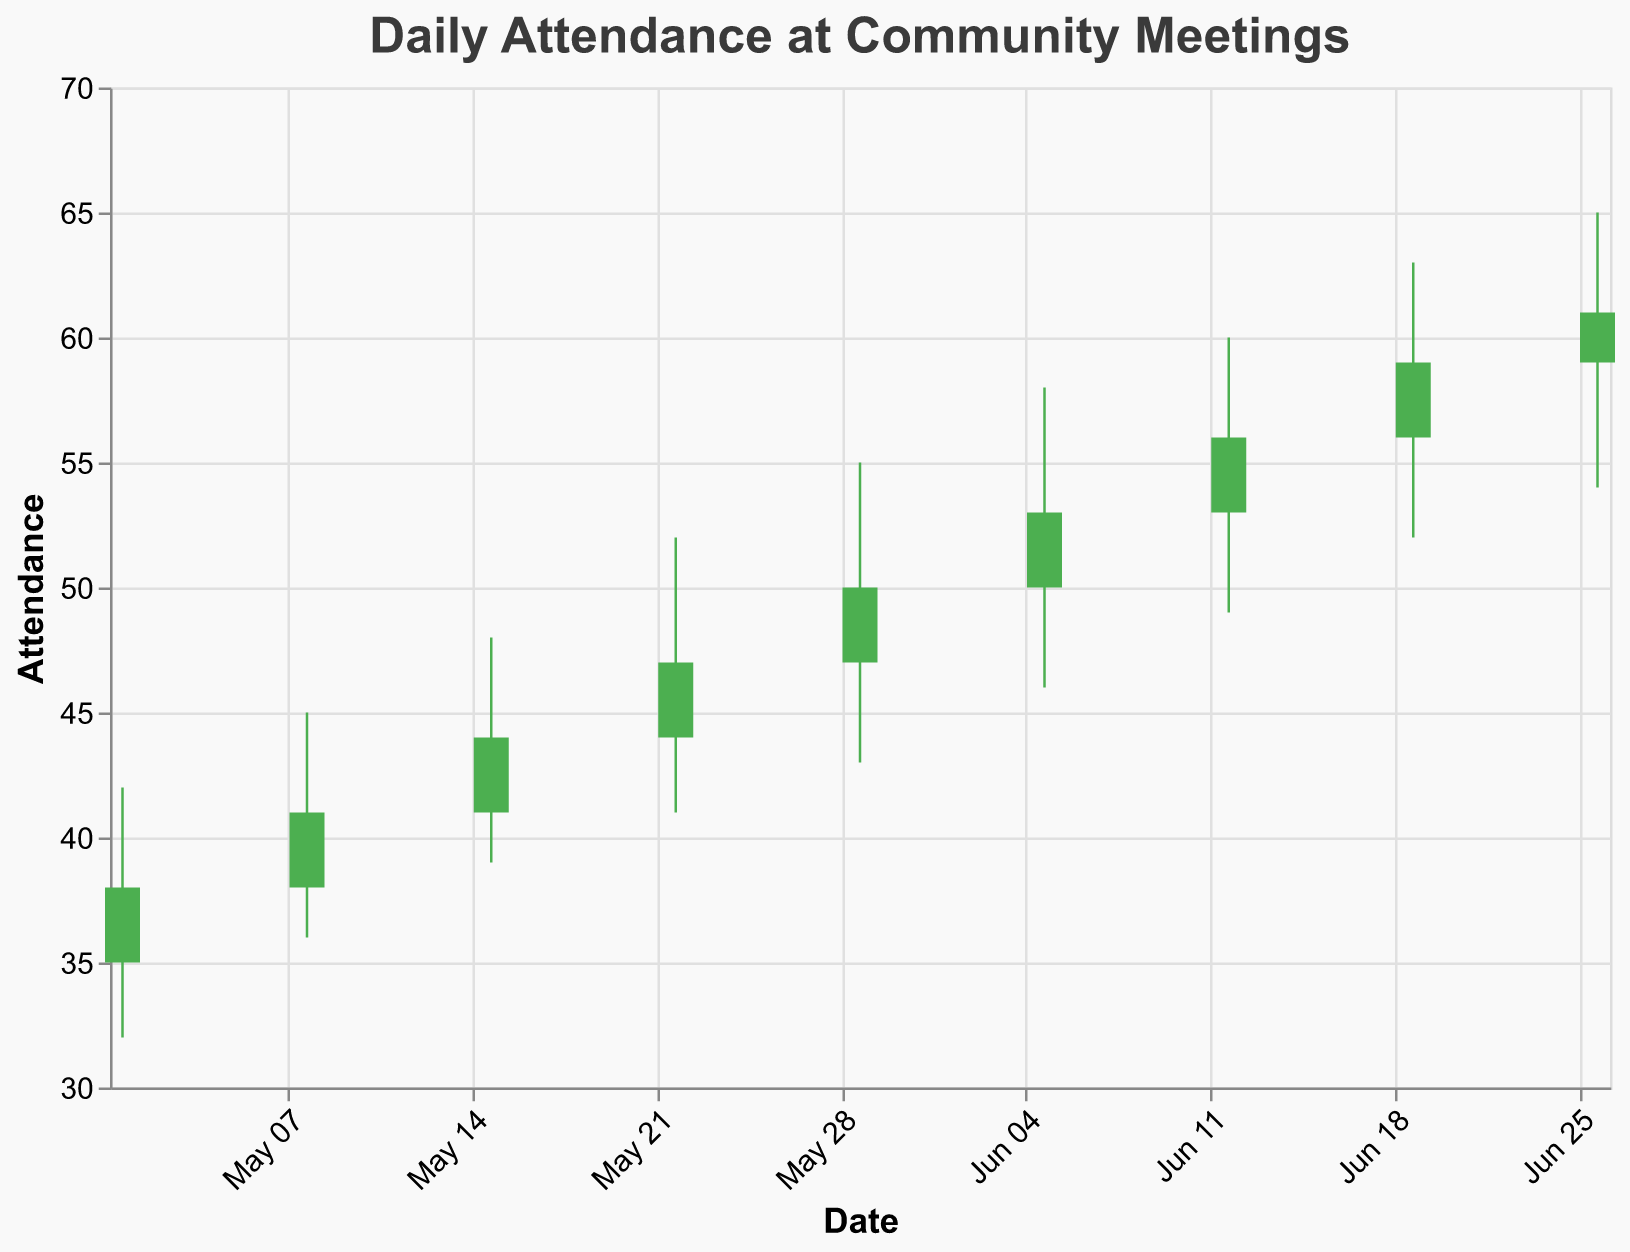What's the title of the chart? The title of the chart is displayed at the top and usually describes the subject of the chart.
Answer: Daily Attendance at Community Meetings How many dates are recorded in the chart? The figure covers the data from May 1, 2023, to June 26, 2023. Counting each weekly data point listed, we get a total of 9 dates.
Answer: 9 On which date did the attendance reach the highest recorded value? By looking at the 'High' values on the y-axis, we compare the highest points for each date. The highest recorded attendance is 65 on June 26, 2023.
Answer: June 26 What was the attendance at the opening and closing on May 22, 2023? Refer to the Open and Close values for May 22: Open was 44 and Close was 47.
Answer: 44 and 47 What is the difference between the highest and lowest attendance on June 12, 2023? For June 12, the High is 60 and the Low is 49. The difference is calculated as 60 - 49.
Answer: 11 Which date had the smallest change between the opening and closing attendance? We need to find the smallest difference between Open and Close for each date. The smallest is on May 22 (47-44=3).
Answer: May 22 Was the attendance generally increasing, decreasing, or fluctuating throughout the period? By looking at the general pattern from the start to the end date, the Open and Close values show an overall increasing trend.
Answer: Increasing On which date was the attendance most volatile? Volatility can be seen where the difference between High and Low is greatest. The most significant difference is on June 26, where it ranges from 65 to 54.
Answer: June 26 For how many dates did the closing attendance exceed the opening attendance? We compare Close and Open values for each date. The attendance closed higher than opened for all dates.
Answer: 9 dates 